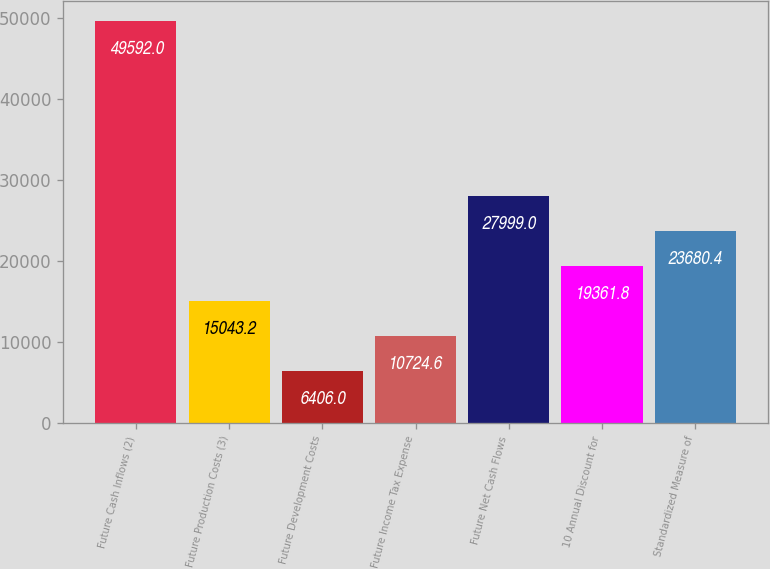Convert chart. <chart><loc_0><loc_0><loc_500><loc_500><bar_chart><fcel>Future Cash Inflows (2)<fcel>Future Production Costs (3)<fcel>Future Development Costs<fcel>Future Income Tax Expense<fcel>Future Net Cash Flows<fcel>10 Annual Discount for<fcel>Standardized Measure of<nl><fcel>49592<fcel>15043.2<fcel>6406<fcel>10724.6<fcel>27999<fcel>19361.8<fcel>23680.4<nl></chart> 